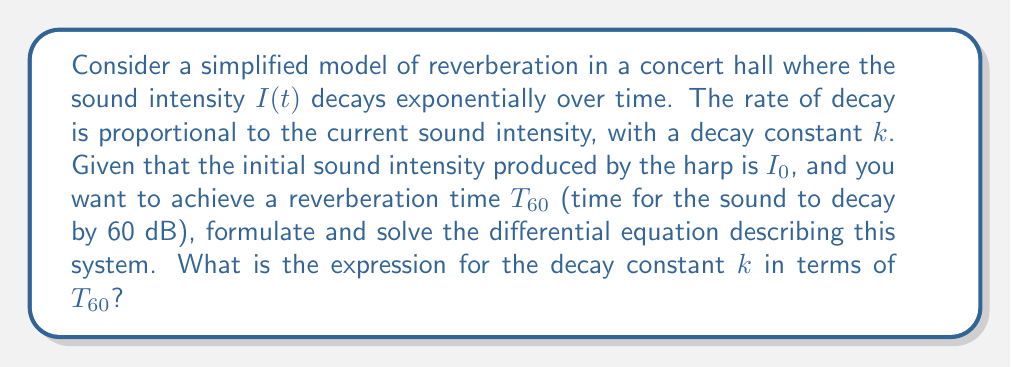Help me with this question. 1) First, we formulate the differential equation:
   $$\frac{dI}{dt} = -kI$$
   This equation states that the rate of change of intensity is proportional to the current intensity, with a negative sign indicating decay.

2) The general solution to this equation is:
   $$I(t) = I_0 e^{-kt}$$
   where $I_0$ is the initial intensity at $t=0$.

3) To find $k$, we use the definition of $T_{60}$. After $T_{60}$ seconds, the intensity should be $10^{-6}$ times the initial intensity (60 dB reduction):
   $$I(T_{60}) = 10^{-6}I_0$$

4) Substituting into our solution:
   $$10^{-6}I_0 = I_0 e^{-kT_{60}}$$

5) Simplifying:
   $$10^{-6} = e^{-kT_{60}}$$

6) Taking the natural logarithm of both sides:
   $$\ln(10^{-6}) = -kT_{60}$$

7) Simplifying the left side:
   $$-6\ln(10) = -kT_{60}$$

8) Solving for $k$:
   $$k = \frac{6\ln(10)}{T_{60}}$$

This expression relates the decay constant $k$ to the reverberation time $T_{60}$, allowing the audio engineer to adjust the effect based on the desired reverberation time.
Answer: $$k = \frac{6\ln(10)}{T_{60}}$$ 